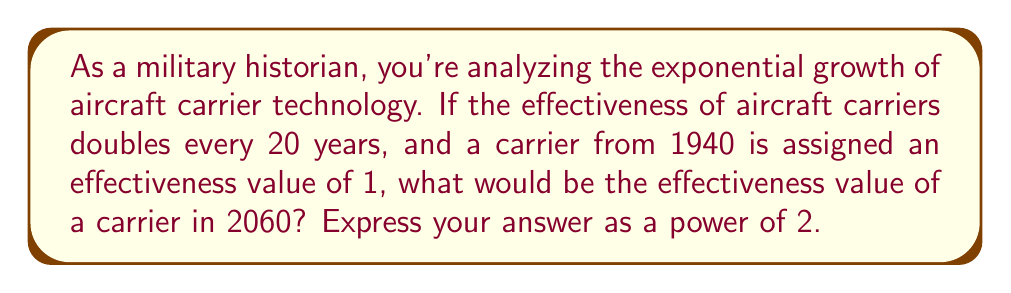Can you answer this question? To solve this problem, we need to follow these steps:

1) First, let's establish our base and time frame:
   - Base effectiveness (1940): 1
   - Doubling period: 20 years
   - Time span: 2060 - 1940 = 120 years

2) We need to determine how many doubling periods occur in 120 years:
   $$ \text{Number of doubling periods} = \frac{120 \text{ years}}{20 \text{ years per doubling}} = 6 $$

3) Now, we can express this as an exponential equation:
   $$ \text{Effectiveness} = 1 \cdot 2^6 $$

   Here, 1 is our base effectiveness, and we're doubling it 6 times.

4) This can be simplified to:
   $$ \text{Effectiveness} = 2^6 $$

Thus, the effectiveness of a carrier in 2060 would be $2^6$ times that of a carrier from 1940.
Answer: $2^6$ 